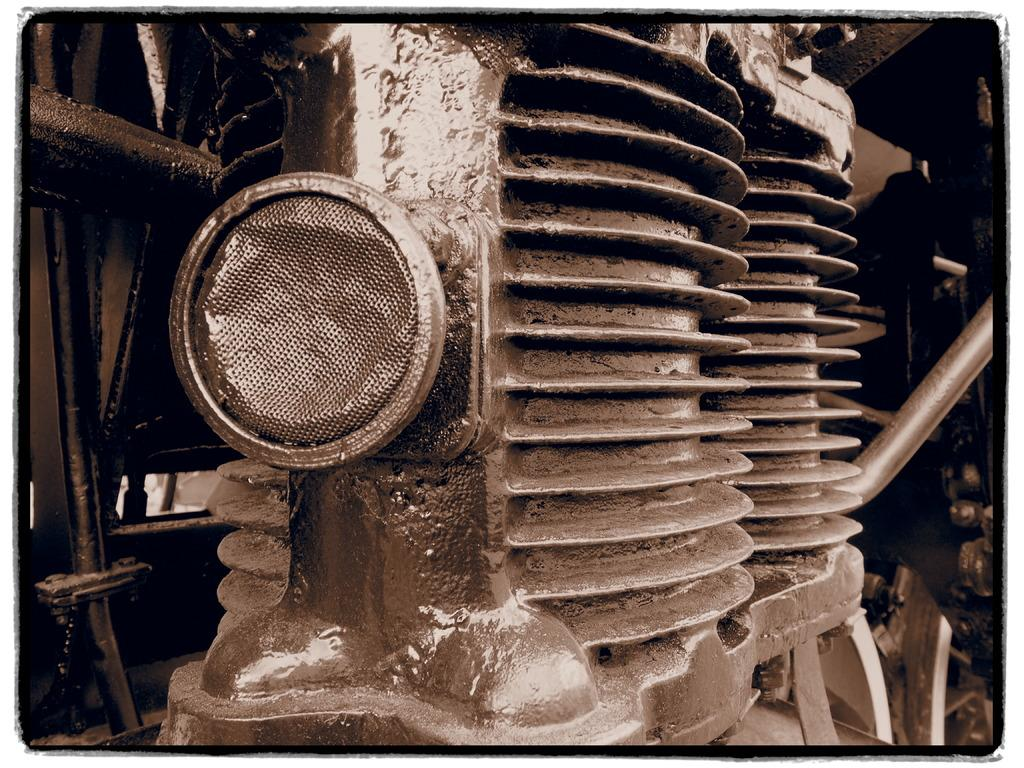What is the main subject in the image? There is a machine in the image. Can you describe the appearance of the machine? The machine is grey in color. What type of care is the machine providing in the image? There is no indication in the image that the machine is providing care, as it is simply a grey machine without any context. 